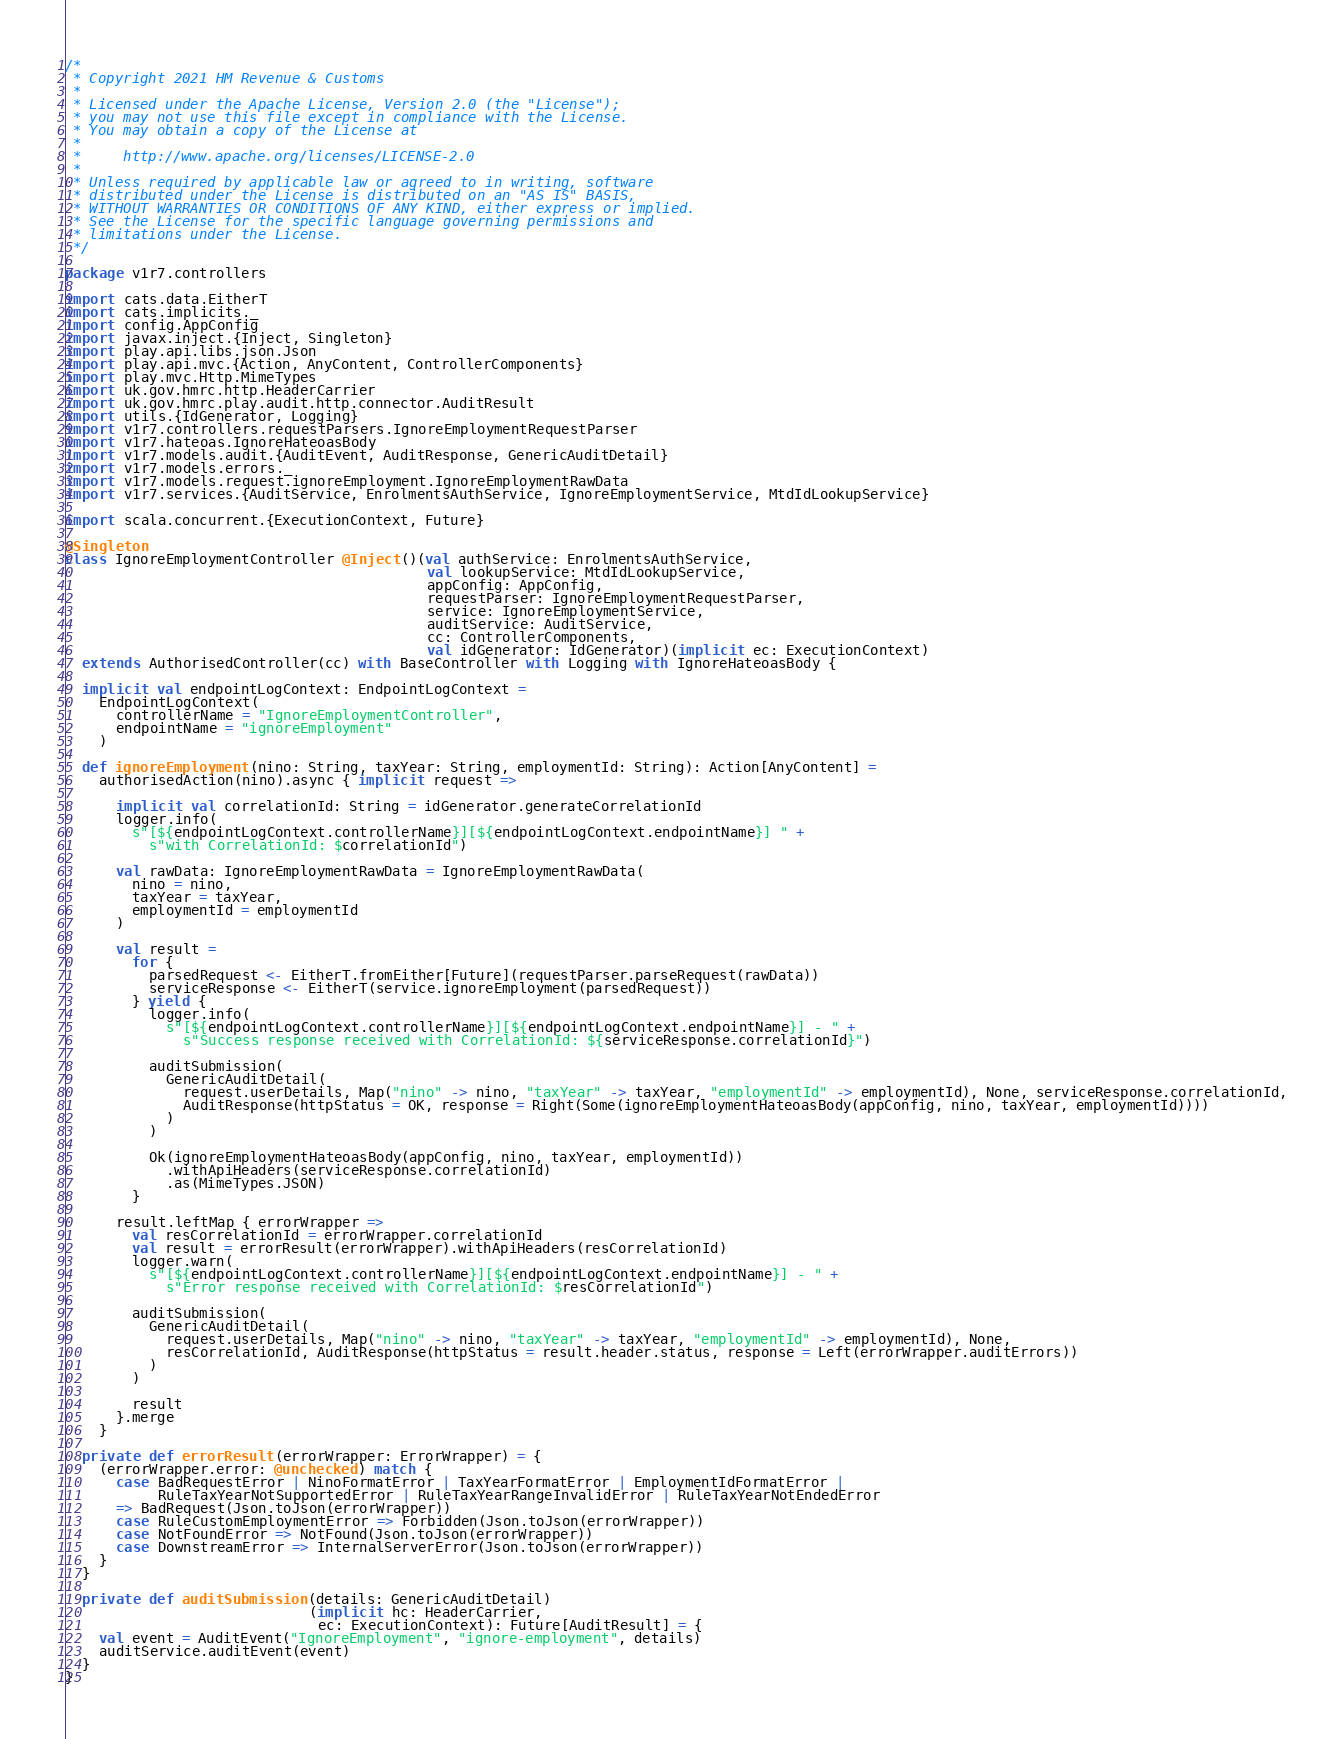Convert code to text. <code><loc_0><loc_0><loc_500><loc_500><_Scala_>/*
 * Copyright 2021 HM Revenue & Customs
 *
 * Licensed under the Apache License, Version 2.0 (the "License");
 * you may not use this file except in compliance with the License.
 * You may obtain a copy of the License at
 *
 *     http://www.apache.org/licenses/LICENSE-2.0
 *
 * Unless required by applicable law or agreed to in writing, software
 * distributed under the License is distributed on an "AS IS" BASIS,
 * WITHOUT WARRANTIES OR CONDITIONS OF ANY KIND, either express or implied.
 * See the License for the specific language governing permissions and
 * limitations under the License.
 */

package v1r7.controllers

import cats.data.EitherT
import cats.implicits._
import config.AppConfig
import javax.inject.{Inject, Singleton}
import play.api.libs.json.Json
import play.api.mvc.{Action, AnyContent, ControllerComponents}
import play.mvc.Http.MimeTypes
import uk.gov.hmrc.http.HeaderCarrier
import uk.gov.hmrc.play.audit.http.connector.AuditResult
import utils.{IdGenerator, Logging}
import v1r7.controllers.requestParsers.IgnoreEmploymentRequestParser
import v1r7.hateoas.IgnoreHateoasBody
import v1r7.models.audit.{AuditEvent, AuditResponse, GenericAuditDetail}
import v1r7.models.errors._
import v1r7.models.request.ignoreEmployment.IgnoreEmploymentRawData
import v1r7.services.{AuditService, EnrolmentsAuthService, IgnoreEmploymentService, MtdIdLookupService}

import scala.concurrent.{ExecutionContext, Future}

@Singleton
class IgnoreEmploymentController @Inject()(val authService: EnrolmentsAuthService,
                                           val lookupService: MtdIdLookupService,
                                           appConfig: AppConfig,
                                           requestParser: IgnoreEmploymentRequestParser,
                                           service: IgnoreEmploymentService,
                                           auditService: AuditService,
                                           cc: ControllerComponents,
                                           val idGenerator: IdGenerator)(implicit ec: ExecutionContext)
  extends AuthorisedController(cc) with BaseController with Logging with IgnoreHateoasBody {

  implicit val endpointLogContext: EndpointLogContext =
    EndpointLogContext(
      controllerName = "IgnoreEmploymentController",
      endpointName = "ignoreEmployment"
    )

  def ignoreEmployment(nino: String, taxYear: String, employmentId: String): Action[AnyContent] =
    authorisedAction(nino).async { implicit request =>

      implicit val correlationId: String = idGenerator.generateCorrelationId
      logger.info(
        s"[${endpointLogContext.controllerName}][${endpointLogContext.endpointName}] " +
          s"with CorrelationId: $correlationId")

      val rawData: IgnoreEmploymentRawData = IgnoreEmploymentRawData(
        nino = nino,
        taxYear = taxYear,
        employmentId = employmentId
      )

      val result =
        for {
          parsedRequest <- EitherT.fromEither[Future](requestParser.parseRequest(rawData))
          serviceResponse <- EitherT(service.ignoreEmployment(parsedRequest))
        } yield {
          logger.info(
            s"[${endpointLogContext.controllerName}][${endpointLogContext.endpointName}] - " +
              s"Success response received with CorrelationId: ${serviceResponse.correlationId}")

          auditSubmission(
            GenericAuditDetail(
              request.userDetails, Map("nino" -> nino, "taxYear" -> taxYear, "employmentId" -> employmentId), None, serviceResponse.correlationId,
              AuditResponse(httpStatus = OK, response = Right(Some(ignoreEmploymentHateoasBody(appConfig, nino, taxYear, employmentId))))
            )
          )

          Ok(ignoreEmploymentHateoasBody(appConfig, nino, taxYear, employmentId))
            .withApiHeaders(serviceResponse.correlationId)
            .as(MimeTypes.JSON)
        }

      result.leftMap { errorWrapper =>
        val resCorrelationId = errorWrapper.correlationId
        val result = errorResult(errorWrapper).withApiHeaders(resCorrelationId)
        logger.warn(
          s"[${endpointLogContext.controllerName}][${endpointLogContext.endpointName}] - " +
            s"Error response received with CorrelationId: $resCorrelationId")

        auditSubmission(
          GenericAuditDetail(
            request.userDetails, Map("nino" -> nino, "taxYear" -> taxYear, "employmentId" -> employmentId), None,
            resCorrelationId, AuditResponse(httpStatus = result.header.status, response = Left(errorWrapper.auditErrors))
          )
        )

        result
      }.merge
    }

  private def errorResult(errorWrapper: ErrorWrapper) = {
    (errorWrapper.error: @unchecked) match {
      case BadRequestError | NinoFormatError | TaxYearFormatError | EmploymentIdFormatError |
           RuleTaxYearNotSupportedError | RuleTaxYearRangeInvalidError | RuleTaxYearNotEndedError
      => BadRequest(Json.toJson(errorWrapper))
      case RuleCustomEmploymentError => Forbidden(Json.toJson(errorWrapper))
      case NotFoundError => NotFound(Json.toJson(errorWrapper))
      case DownstreamError => InternalServerError(Json.toJson(errorWrapper))
    }
  }

  private def auditSubmission(details: GenericAuditDetail)
                             (implicit hc: HeaderCarrier,
                              ec: ExecutionContext): Future[AuditResult] = {
    val event = AuditEvent("IgnoreEmployment", "ignore-employment", details)
    auditService.auditEvent(event)
  }
}</code> 